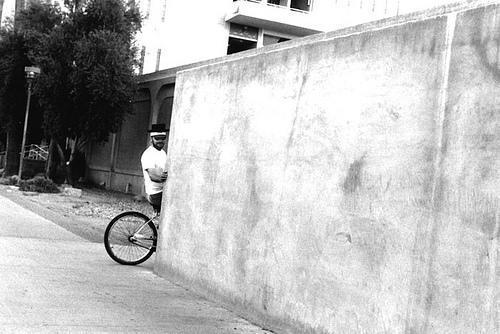How many people are pictured?
Give a very brief answer. 1. 